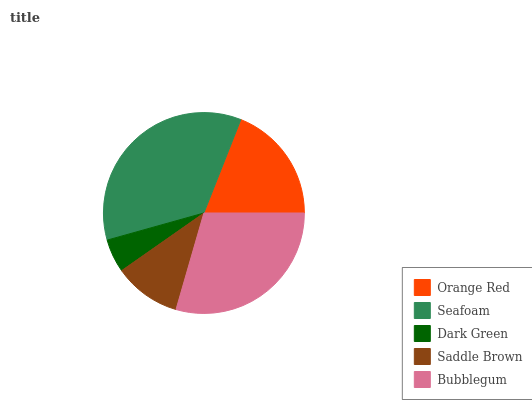Is Dark Green the minimum?
Answer yes or no. Yes. Is Seafoam the maximum?
Answer yes or no. Yes. Is Seafoam the minimum?
Answer yes or no. No. Is Dark Green the maximum?
Answer yes or no. No. Is Seafoam greater than Dark Green?
Answer yes or no. Yes. Is Dark Green less than Seafoam?
Answer yes or no. Yes. Is Dark Green greater than Seafoam?
Answer yes or no. No. Is Seafoam less than Dark Green?
Answer yes or no. No. Is Orange Red the high median?
Answer yes or no. Yes. Is Orange Red the low median?
Answer yes or no. Yes. Is Dark Green the high median?
Answer yes or no. No. Is Dark Green the low median?
Answer yes or no. No. 